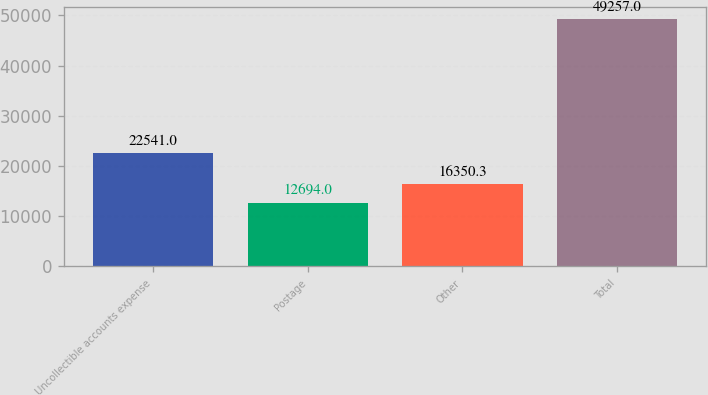Convert chart. <chart><loc_0><loc_0><loc_500><loc_500><bar_chart><fcel>Uncollectible accounts expense<fcel>Postage<fcel>Other<fcel>Total<nl><fcel>22541<fcel>12694<fcel>16350.3<fcel>49257<nl></chart> 